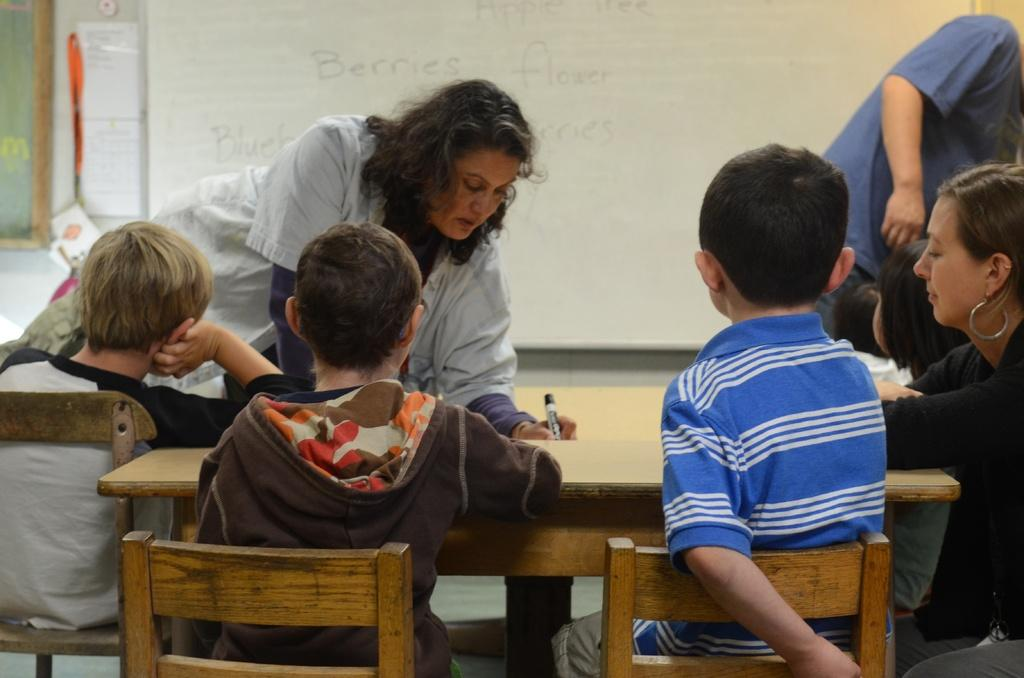What are the children doing in the image? The children are sitting on chairs in the image. What are the people in the image doing? There are people standing in the image. What can be seen in the background of the image? There is a whiteboard visible in the background of the image. What type of unit is being discussed by the children in the image? There is no indication in the image that the children are discussing any units. 